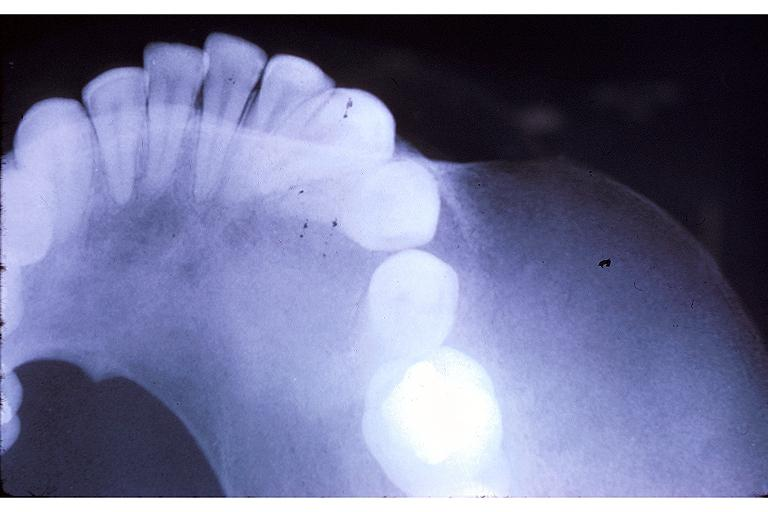does lower chest and abdomen anterior show fibrous dysplasia?
Answer the question using a single word or phrase. No 